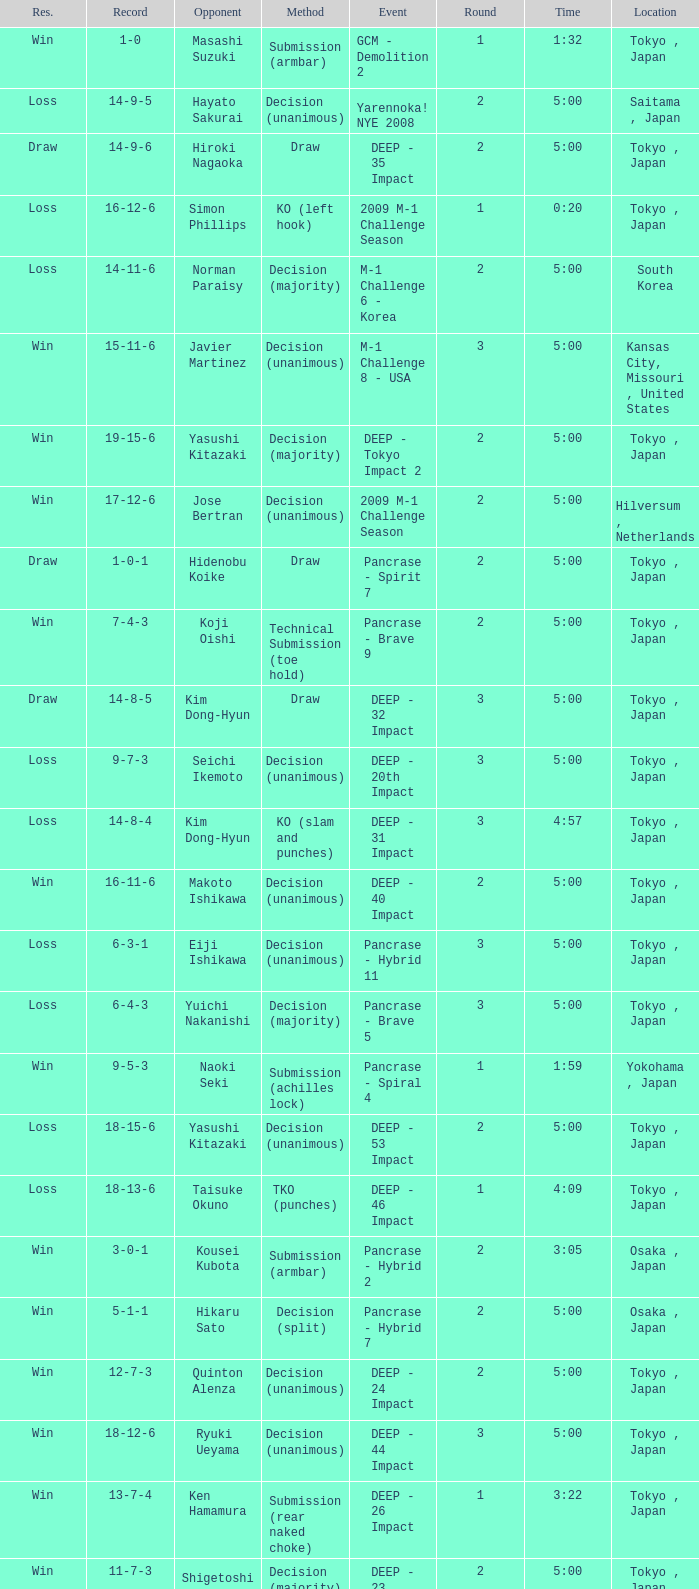Help me parse the entirety of this table. {'header': ['Res.', 'Record', 'Opponent', 'Method', 'Event', 'Round', 'Time', 'Location'], 'rows': [['Win', '1-0', 'Masashi Suzuki', 'Submission (armbar)', 'GCM - Demolition 2', '1', '1:32', 'Tokyo , Japan'], ['Loss', '14-9-5', 'Hayato Sakurai', 'Decision (unanimous)', 'Yarennoka! NYE 2008', '2', '5:00', 'Saitama , Japan'], ['Draw', '14-9-6', 'Hiroki Nagaoka', 'Draw', 'DEEP - 35 Impact', '2', '5:00', 'Tokyo , Japan'], ['Loss', '16-12-6', 'Simon Phillips', 'KO (left hook)', '2009 M-1 Challenge Season', '1', '0:20', 'Tokyo , Japan'], ['Loss', '14-11-6', 'Norman Paraisy', 'Decision (majority)', 'M-1 Challenge 6 - Korea', '2', '5:00', 'South Korea'], ['Win', '15-11-6', 'Javier Martinez', 'Decision (unanimous)', 'M-1 Challenge 8 - USA', '3', '5:00', 'Kansas City, Missouri , United States'], ['Win', '19-15-6', 'Yasushi Kitazaki', 'Decision (majority)', 'DEEP - Tokyo Impact 2', '2', '5:00', 'Tokyo , Japan'], ['Win', '17-12-6', 'Jose Bertran', 'Decision (unanimous)', '2009 M-1 Challenge Season', '2', '5:00', 'Hilversum , Netherlands'], ['Draw', '1-0-1', 'Hidenobu Koike', 'Draw', 'Pancrase - Spirit 7', '2', '5:00', 'Tokyo , Japan'], ['Win', '7-4-3', 'Koji Oishi', 'Technical Submission (toe hold)', 'Pancrase - Brave 9', '2', '5:00', 'Tokyo , Japan'], ['Draw', '14-8-5', 'Kim Dong-Hyun', 'Draw', 'DEEP - 32 Impact', '3', '5:00', 'Tokyo , Japan'], ['Loss', '9-7-3', 'Seichi Ikemoto', 'Decision (unanimous)', 'DEEP - 20th Impact', '3', '5:00', 'Tokyo , Japan'], ['Loss', '14-8-4', 'Kim Dong-Hyun', 'KO (slam and punches)', 'DEEP - 31 Impact', '3', '4:57', 'Tokyo , Japan'], ['Win', '16-11-6', 'Makoto Ishikawa', 'Decision (unanimous)', 'DEEP - 40 Impact', '2', '5:00', 'Tokyo , Japan'], ['Loss', '6-3-1', 'Eiji Ishikawa', 'Decision (unanimous)', 'Pancrase - Hybrid 11', '3', '5:00', 'Tokyo , Japan'], ['Loss', '6-4-3', 'Yuichi Nakanishi', 'Decision (majority)', 'Pancrase - Brave 5', '3', '5:00', 'Tokyo , Japan'], ['Win', '9-5-3', 'Naoki Seki', 'Submission (achilles lock)', 'Pancrase - Spiral 4', '1', '1:59', 'Yokohama , Japan'], ['Loss', '18-15-6', 'Yasushi Kitazaki', 'Decision (unanimous)', 'DEEP - 53 Impact', '2', '5:00', 'Tokyo , Japan'], ['Loss', '18-13-6', 'Taisuke Okuno', 'TKO (punches)', 'DEEP - 46 Impact', '1', '4:09', 'Tokyo , Japan'], ['Win', '3-0-1', 'Kousei Kubota', 'Submission (armbar)', 'Pancrase - Hybrid 2', '2', '3:05', 'Osaka , Japan'], ['Win', '5-1-1', 'Hikaru Sato', 'Decision (split)', 'Pancrase - Hybrid 7', '2', '5:00', 'Osaka , Japan'], ['Win', '12-7-3', 'Quinton Alenza', 'Decision (unanimous)', 'DEEP - 24 Impact', '2', '5:00', 'Tokyo , Japan'], ['Win', '18-12-6', 'Ryuki Ueyama', 'Decision (unanimous)', 'DEEP - 44 Impact', '3', '5:00', 'Tokyo , Japan'], ['Win', '13-7-4', 'Ken Hamamura', 'Submission (rear naked choke)', 'DEEP - 26 Impact', '1', '3:22', 'Tokyo , Japan'], ['Win', '11-7-3', 'Shigetoshi Iwase', 'Decision (majority)', 'DEEP - 23 Impact', '2', '5:00', 'Tokyo , Japan'], ['Loss', '8-5-3', 'Satoru Kitaoka', 'Decision (split)', 'Pancrase - Spiral 2', '3', '5:00', 'Yokohama , Japan'], ['Win', '8-4-3', 'Hidetaka Monma', 'Decision (unanimous)', 'Pancrase - Brave 12', '3', '5:00', 'Tokyo , Japan'], ['Win', '14-7-4', 'Jutaro Nakao', 'Decision (majority)', 'DEEP - 28 Impact', '3', '5:00', 'Tokyo , Japan'], ['Loss', '9-6-3', 'Nobuhiro Obiya', 'Decision (unanimous)', 'DEEP - 19th Impact', '3', '5:00', 'Tokyo , Japan'], ['Draw', '6-3-2', 'Tetsuji Chikada', 'Draw', 'DEEP - clubDEEP Fukuoka: Team ROKEN Festival', '2', '5:00', 'Fukuoka , Japan'], ['Draw', '6-3-3', 'Seiki Ryo', 'Draw', 'Pancrase - Brave 3', '2', '5:00', 'Tokyo , Japan'], ['Loss', '19-16-6', 'Toshihiro Shimizu', 'Decision (unanimous)', 'DEEP - Cage Impact 2012 in Tokyo: Over Again', '2', '5:00', 'Tokyo , Japan'], ['Loss', '19-17-6', 'Takahiro Kawanaka', 'Submission (anaconda choke)', 'DEEP - 60 Impact', '1', '1:38', 'Tokyo , Japan'], ['Win', '2-0-1', 'Motohiro Tachihara', 'Submission (armbar)', 'GCM - Demolition 3', '2', '1:54', 'Tokyo , Japan'], ['Loss', '4-1-1', 'Yushin Okami', 'Decision (unanimous)', 'GCM - Demolition 7', '2', '5:00', 'Tokyo , Japan'], ['Win', '6-1-1', 'Ryoji Suzuki', 'Decision (unanimous)', 'GCM - Demolition 9', '2', '5:00', 'Yokohama , Japan'], ['Win', '4-0-1', 'Daisuke Nakamura', 'Decision (unanimous)', 'GCM - Demolition 6', '2', '5:00', 'Japan'], ['Loss', '18-14-6', 'Yoshitomo Watanabe', 'TKO (punches)', 'DEEP - 51 Impact', '1', '2:48', 'Tokyo , Japan'], ['Loss', '6-2-1', 'Yuji Hisamatsu', 'KO (kick)', 'GCM - Demolition 10', '2', '2:08', 'Japan'], ['Draw', '12-7-4', 'Ryan Bow', 'Draw', 'DEEP - 25th Impact', '2', '5:00', 'Tokyo , Japan'], ['Win', '10-7-3', 'Daisuke Nakamura', 'Decision (unanimous)', 'DEEP - 22 Impact', '2', '5:00', 'Tokyo , Japan'], ['Loss', '14-10-6', 'Seichi Ikemoto', 'Decision (unanimous)', 'DEEP - 36 Impact', '3', '5:00', 'Osaka , Japan']]} What is the location when the method is tko (punches) and the time is 2:48? Tokyo , Japan. 